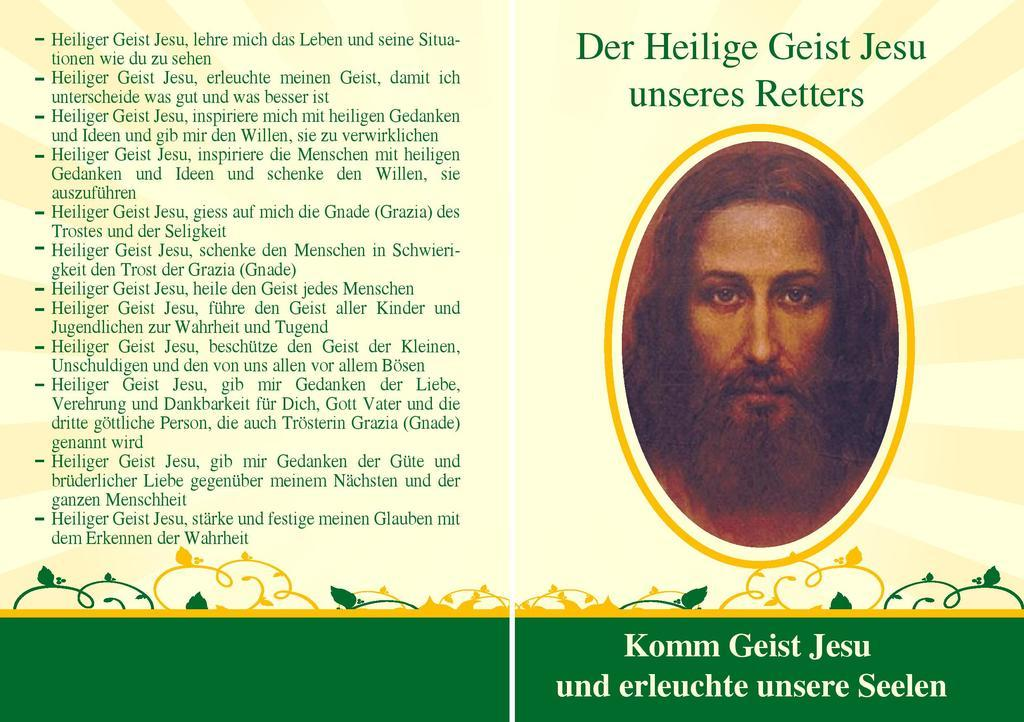What is present on the poster in the image? There is a poster in the image, which contains an image of a person and some information. Can you describe the image on the poster? The image on the poster is of a person. What else can be found on the poster besides the image? The poster contains some information. How many yaks are visible in the image? There are no yaks present in the image; the poster contains an image of a person and some information. 